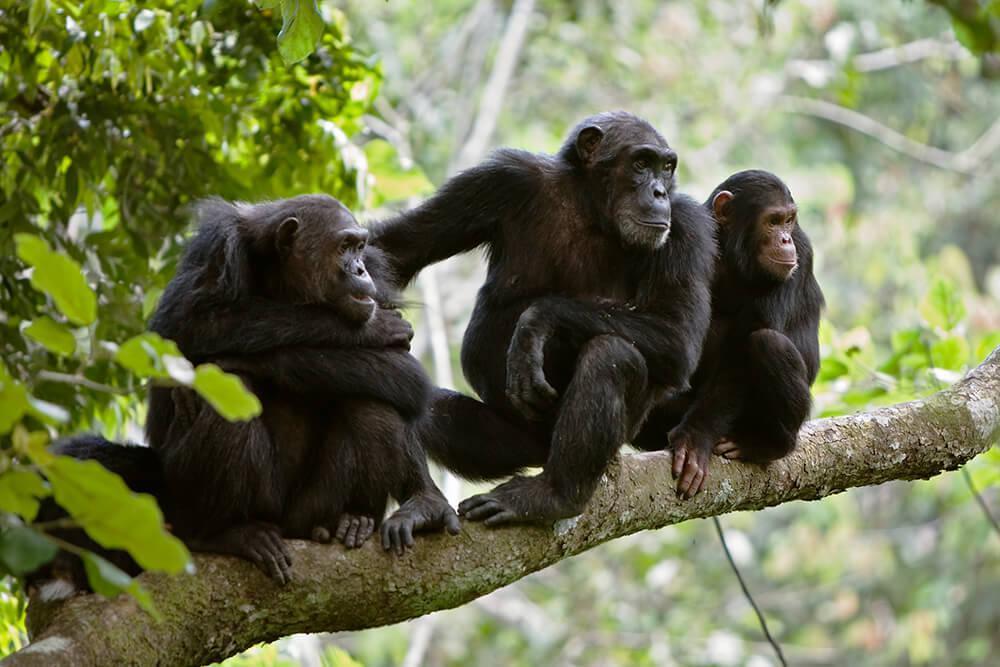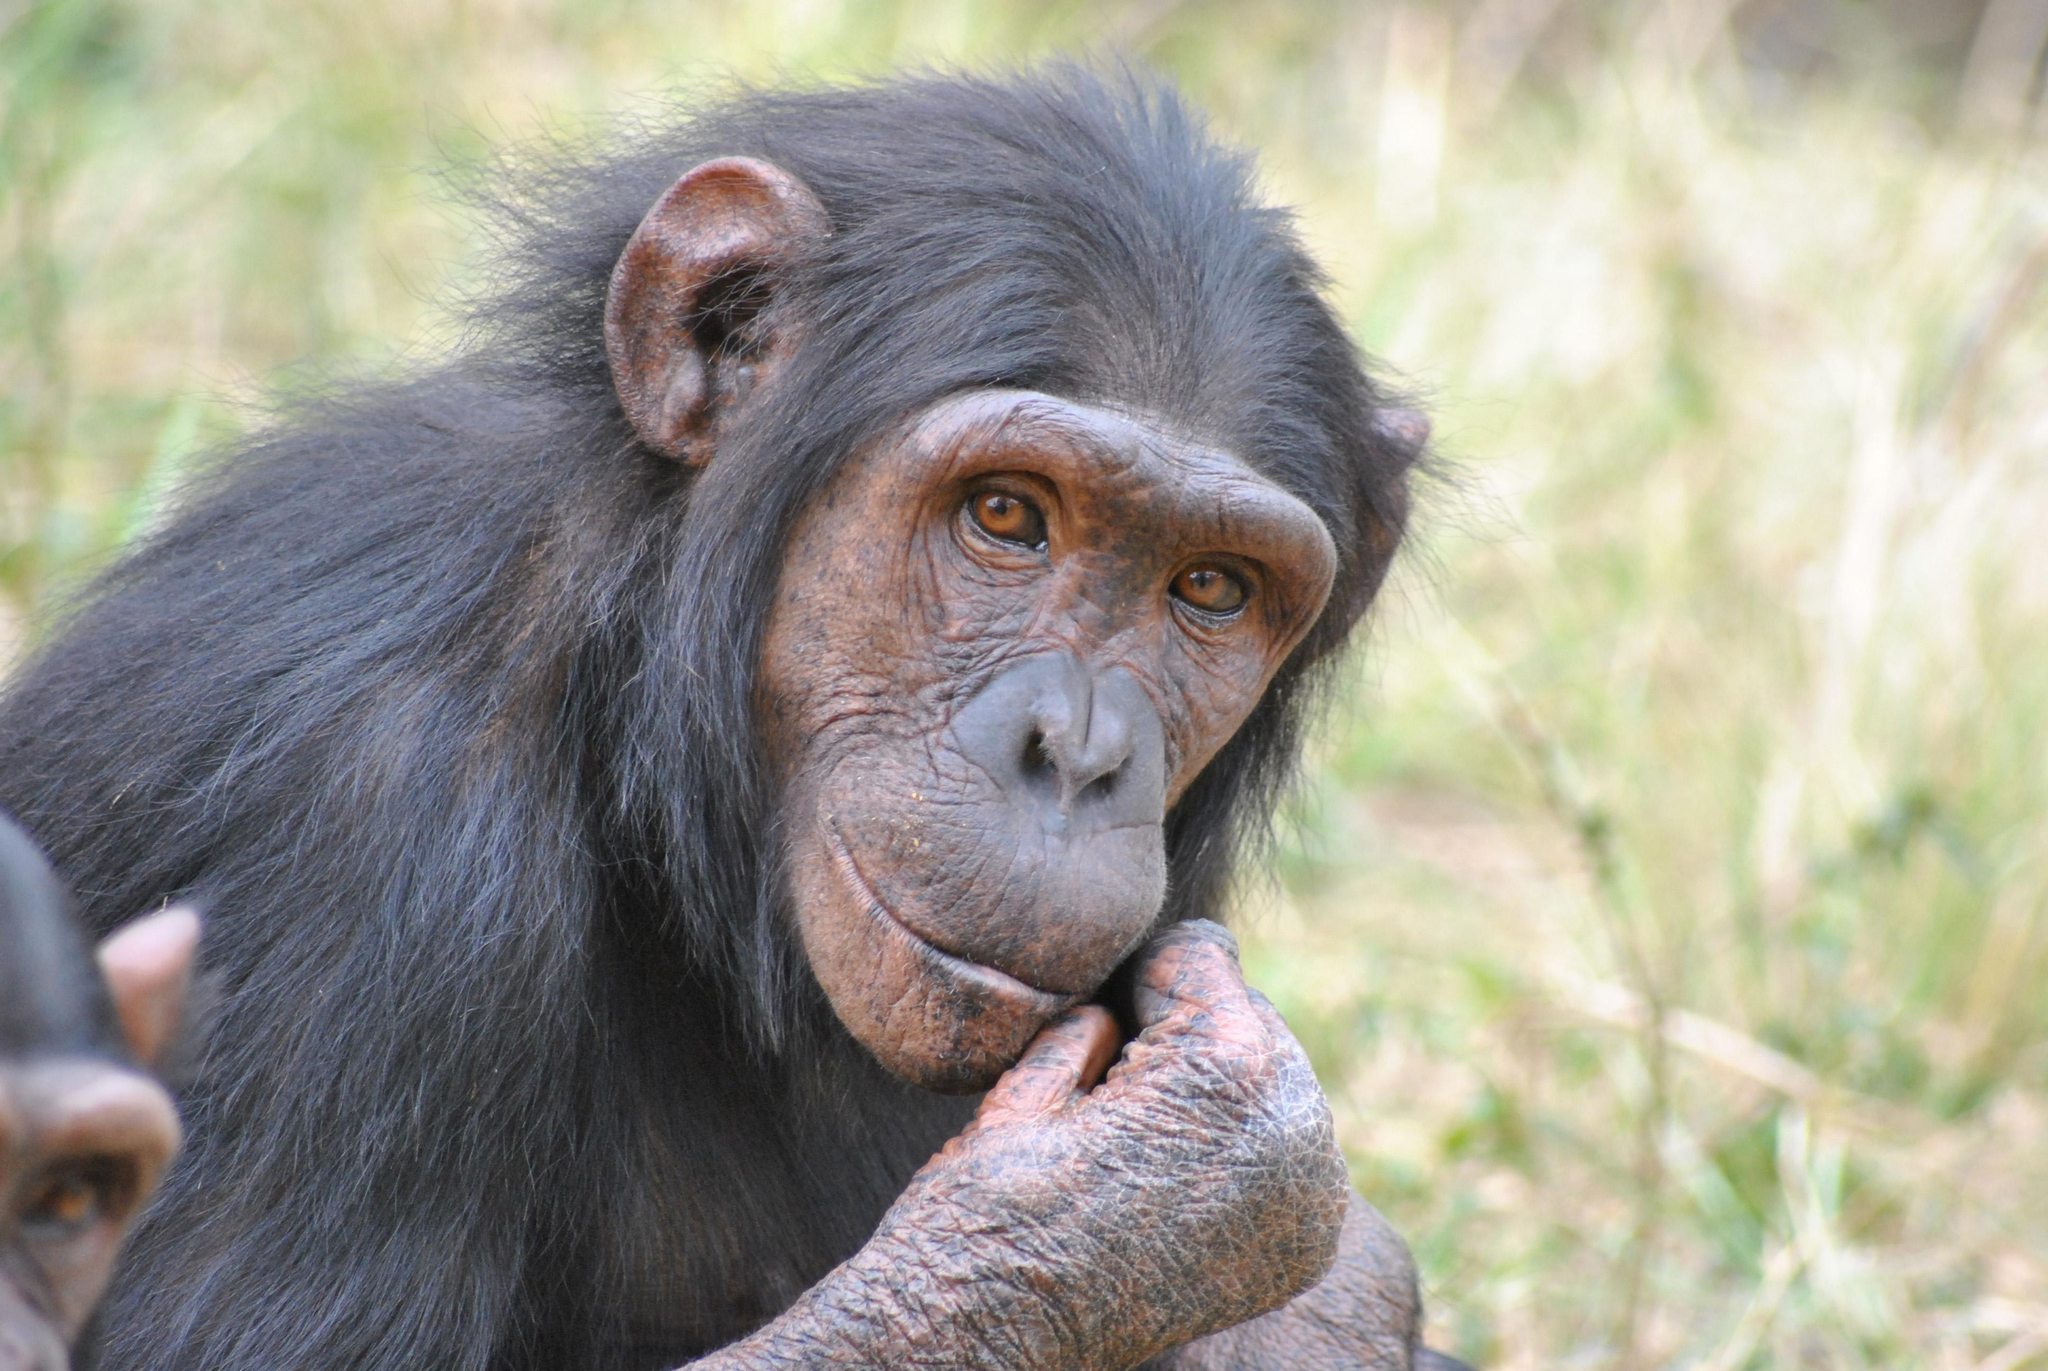The first image is the image on the left, the second image is the image on the right. Assess this claim about the two images: "There is exactly one animal in the image on the left.". Correct or not? Answer yes or no. No. 